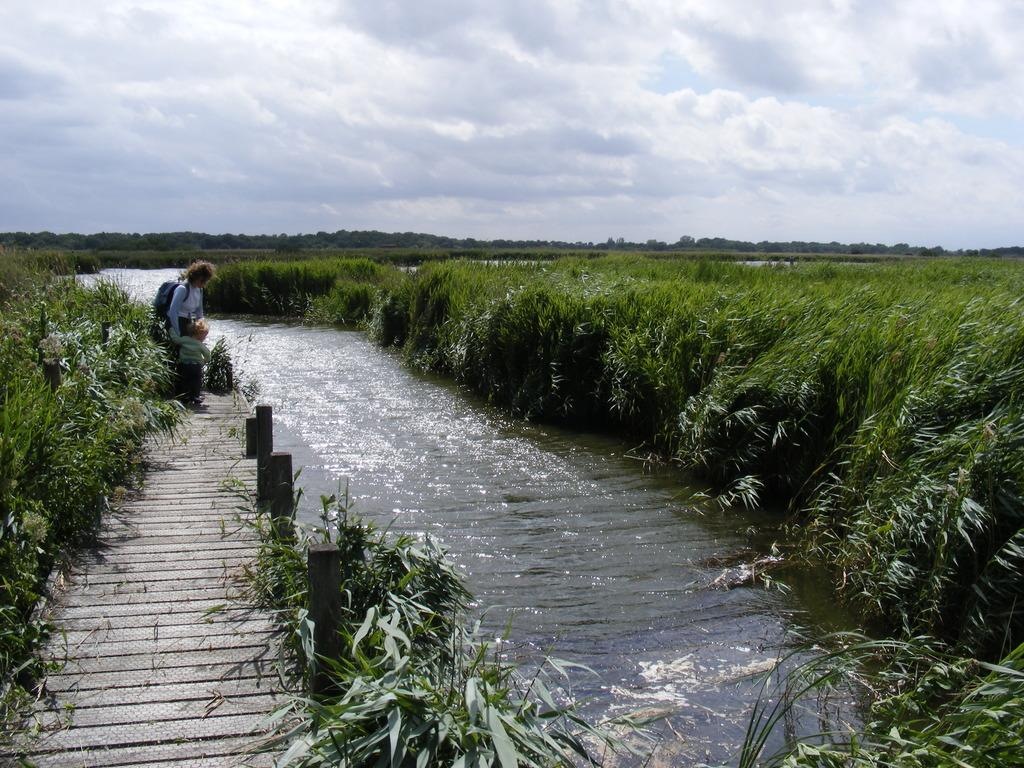What is the main feature of the image? The main feature of the image is a canal with water flowing. What is located near the canal? There is a wooden platform in the image. Who is standing on the wooden platform? A person and a kid are standing on the wooden platform. What else can be seen in the image besides the canal and wooden platform? There are plants and the sky visible in the image. What type of crayon is the kid using to color the wooden platform in the image? There is no crayon or coloring activity present in the image. How does the police officer help the person and kid on the wooden platform in the image? There is no police officer present in the image. 